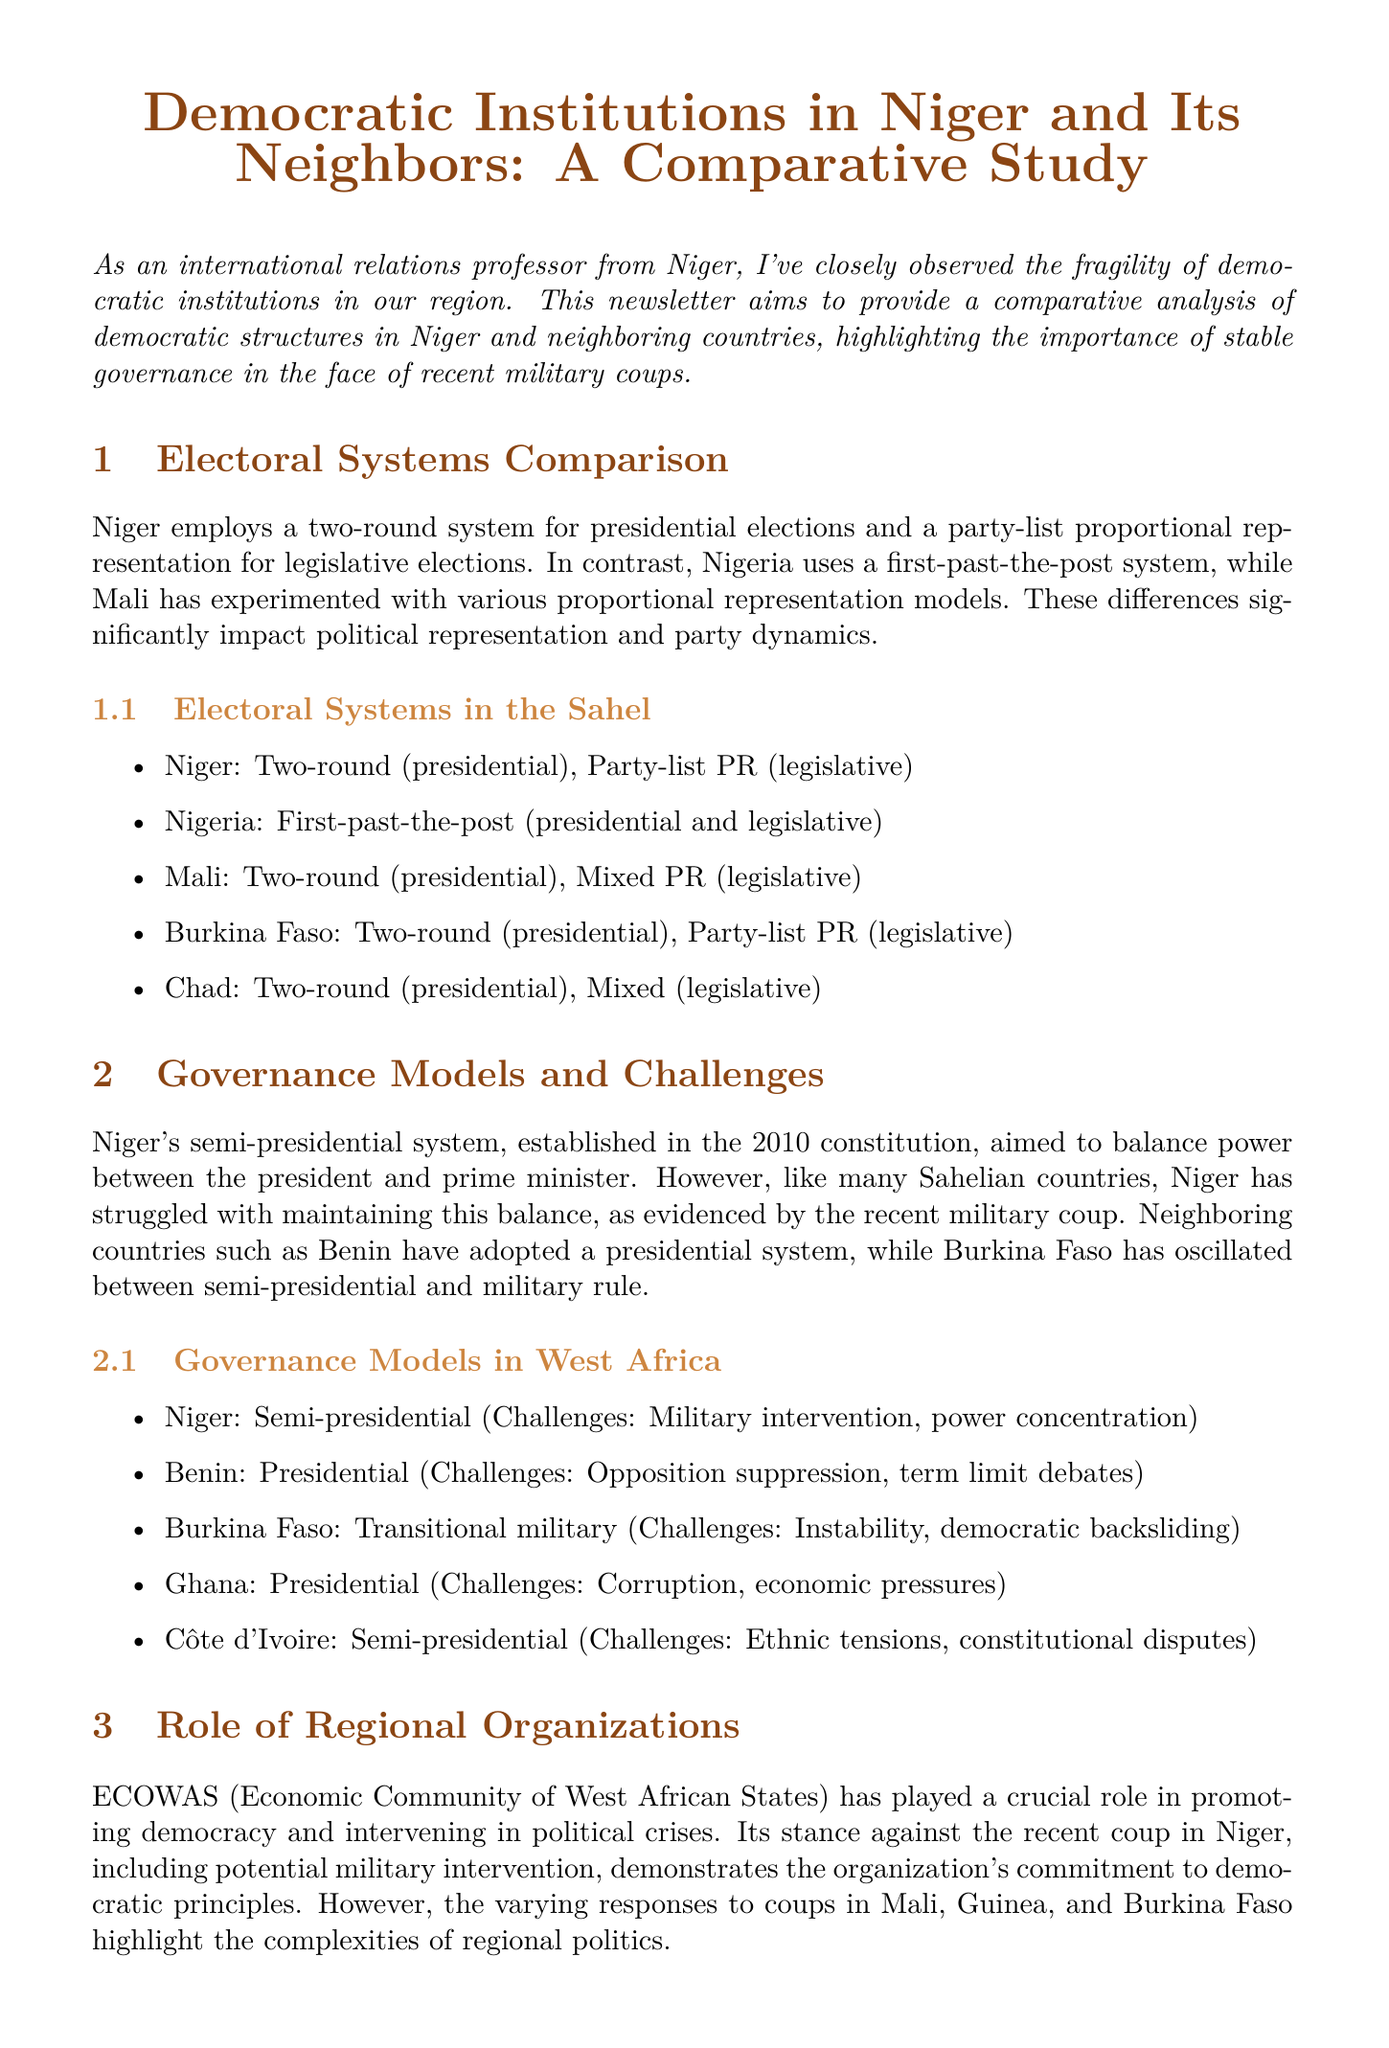What is the title of the newsletter? The title of the newsletter is prominently stated at the beginning of the document.
Answer: Democratic Institutions in Niger and Its Neighbors: A Comparative Study Which electoral system does Niger use for presidential elections? The document specifies the electoral system employed by Niger for presidential elections.
Answer: Two-round What challenges does Niger face in its governance model? The document outlines the specific challenges associated with Niger's governance model.
Answer: Military intervention, power concentration Which country has a presidential governance model? The document lists several governance models; this question asks for a specific country that uses the presidential model.
Answer: Benin What is the key role of ECOWAS mentioned in the document? The newsletter discusses the role of ECOWAS in promoting democracy and intervening in political crises.
Answer: Promoting democracy Who is the author of the newsletter? The document provides information about the authorship at the end.
Answer: Dr. Amadou Issoufou What grassroots movement is highlighted in Senegal? The newsletter names specific movements that advocate democratic principles, including one in Senegal.
Answer: Y'en a Marre How many countries' electoral systems are compared in the document? The infographic section details the electoral systems of several countries, allowing a count.
Answer: Five 